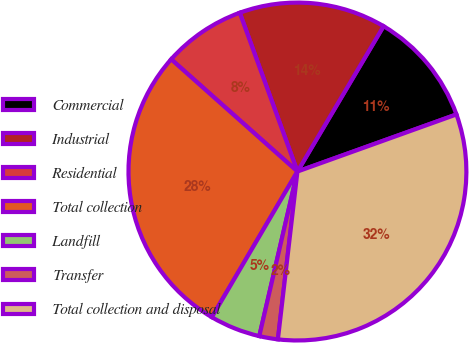Convert chart to OTSL. <chart><loc_0><loc_0><loc_500><loc_500><pie_chart><fcel>Commercial<fcel>Industrial<fcel>Residential<fcel>Total collection<fcel>Landfill<fcel>Transfer<fcel>Total collection and disposal<nl><fcel>11.0%<fcel>14.06%<fcel>7.89%<fcel>28.11%<fcel>4.83%<fcel>1.78%<fcel>32.33%<nl></chart> 